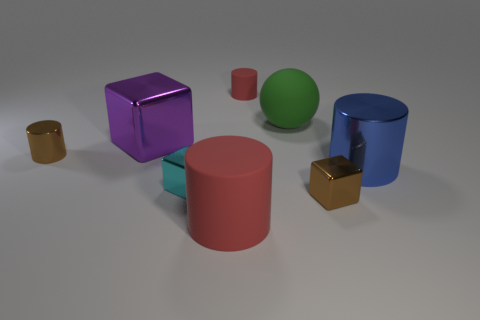There is a shiny object that is the same color as the small shiny cylinder; what is its shape? The shiny object that shares the same color as the small cylinder is shaped like a cube. This cube, with its lustrous purple surface, provides a contrast in form to its cylindrical counterpart. 